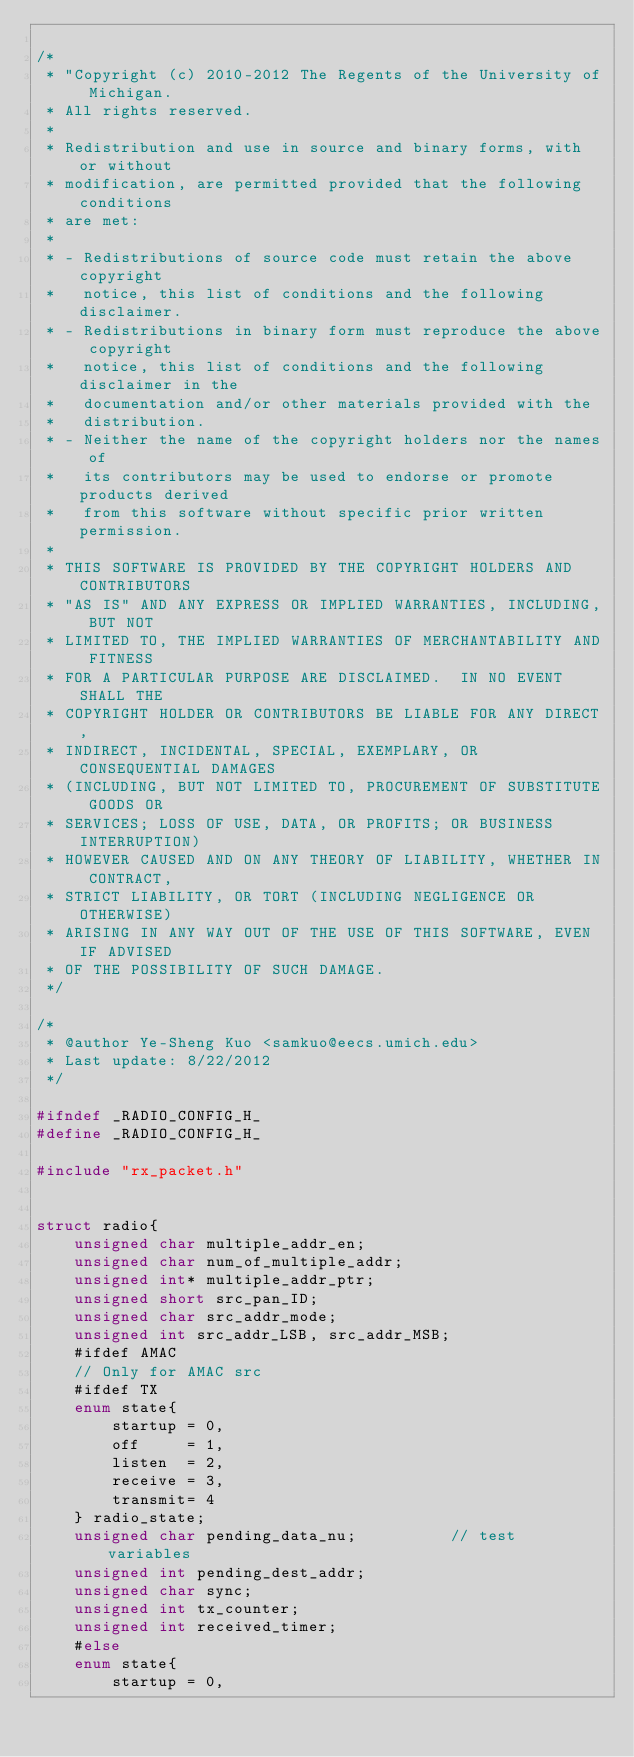Convert code to text. <code><loc_0><loc_0><loc_500><loc_500><_C_>
/*
 * "Copyright (c) 2010-2012 The Regents of the University of Michigan.
 * All rights reserved.
 *
 * Redistribution and use in source and binary forms, with or without
 * modification, are permitted provided that the following conditions
 * are met:
 *
 * - Redistributions of source code must retain the above copyright
 *   notice, this list of conditions and the following disclaimer.
 * - Redistributions in binary form must reproduce the above copyright
 *   notice, this list of conditions and the following disclaimer in the
 *   documentation and/or other materials provided with the
 *   distribution.
 * - Neither the name of the copyright holders nor the names of
 *   its contributors may be used to endorse or promote products derived
 *   from this software without specific prior written permission.
 *
 * THIS SOFTWARE IS PROVIDED BY THE COPYRIGHT HOLDERS AND CONTRIBUTORS
 * "AS IS" AND ANY EXPRESS OR IMPLIED WARRANTIES, INCLUDING, BUT NOT
 * LIMITED TO, THE IMPLIED WARRANTIES OF MERCHANTABILITY AND FITNESS
 * FOR A PARTICULAR PURPOSE ARE DISCLAIMED.  IN NO EVENT SHALL THE
 * COPYRIGHT HOLDER OR CONTRIBUTORS BE LIABLE FOR ANY DIRECT,
 * INDIRECT, INCIDENTAL, SPECIAL, EXEMPLARY, OR CONSEQUENTIAL DAMAGES
 * (INCLUDING, BUT NOT LIMITED TO, PROCUREMENT OF SUBSTITUTE GOODS OR
 * SERVICES; LOSS OF USE, DATA, OR PROFITS; OR BUSINESS INTERRUPTION)
 * HOWEVER CAUSED AND ON ANY THEORY OF LIABILITY, WHETHER IN CONTRACT,
 * STRICT LIABILITY, OR TORT (INCLUDING NEGLIGENCE OR OTHERWISE)
 * ARISING IN ANY WAY OUT OF THE USE OF THIS SOFTWARE, EVEN IF ADVISED
 * OF THE POSSIBILITY OF SUCH DAMAGE.
 */

/*
 * @author Ye-Sheng Kuo <samkuo@eecs.umich.edu>
 * Last update: 8/22/2012
 */

#ifndef _RADIO_CONFIG_H_ 
#define _RADIO_CONFIG_H_ 

#include "rx_packet.h"


struct radio{
	unsigned char multiple_addr_en;
	unsigned char num_of_multiple_addr;
	unsigned int* multiple_addr_ptr;
	unsigned short src_pan_ID;
	unsigned char src_addr_mode;
	unsigned int src_addr_LSB, src_addr_MSB;
	#ifdef AMAC
	// Only for AMAC src
	#ifdef TX
	enum state{
		startup = 0,
		off		= 1,
		listen	= 2,
		receive	= 3,
		transmit= 4
	} radio_state;
	unsigned char pending_data_nu;			// test variables
	unsigned int pending_dest_addr;
	unsigned char sync;
	unsigned int tx_counter;
	unsigned int received_timer;
	#else
	enum state{
		startup = 0,</code> 